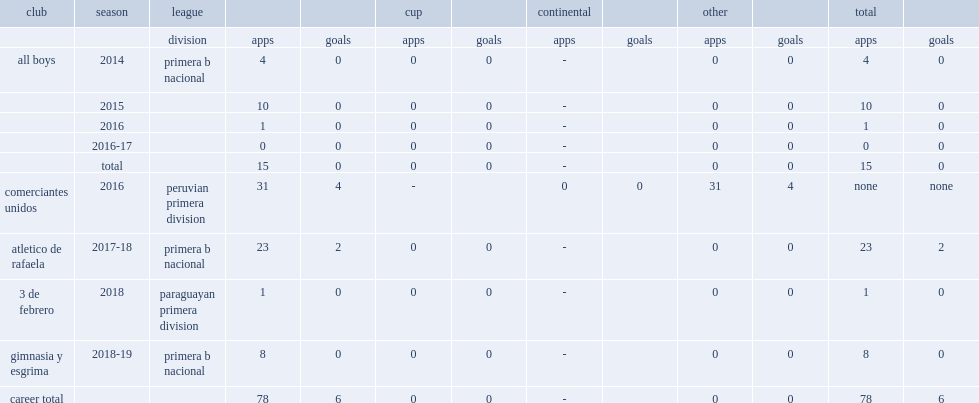In 2014, which league did stefano brundo play for all boys in the league? Primera b nacional. 